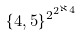Convert formula to latex. <formula><loc_0><loc_0><loc_500><loc_500>\{ 4 , 5 \} ^ { 2 ^ { 2 ^ { \aleph _ { 4 } } } }</formula> 